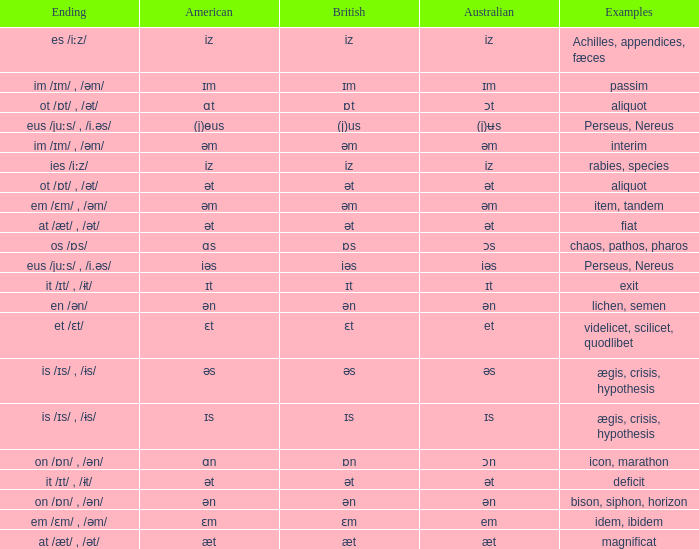Which australian possesses british of ɒs? Ɔs. 